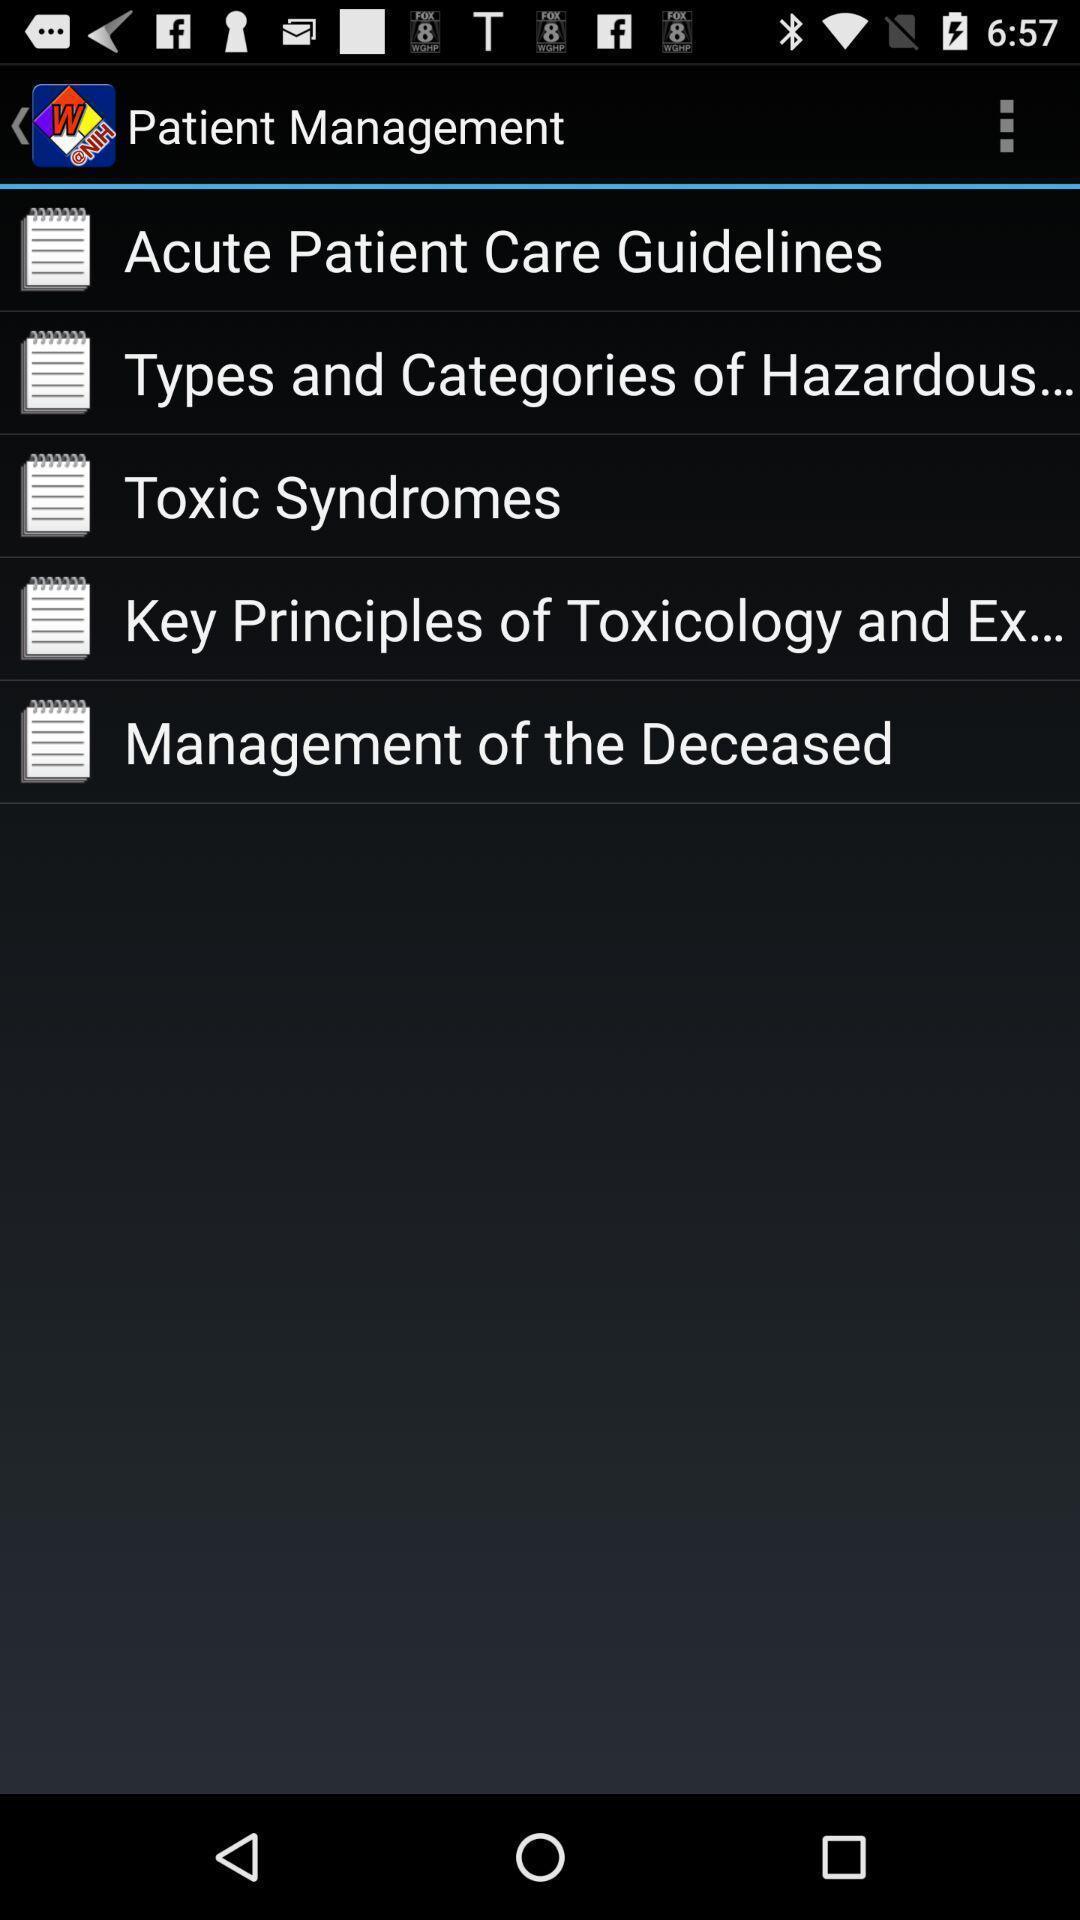Explain the elements present in this screenshot. Screen displaying notes. 